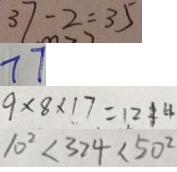<formula> <loc_0><loc_0><loc_500><loc_500>3 7 - 2 = 3 5 
 7 7 
 9 \times 8 \times 1 7 = 1 2 1 4 
 1 0 ^ { 2 } < 3 2 4 < 5 0 ^ { 2 }</formula> 